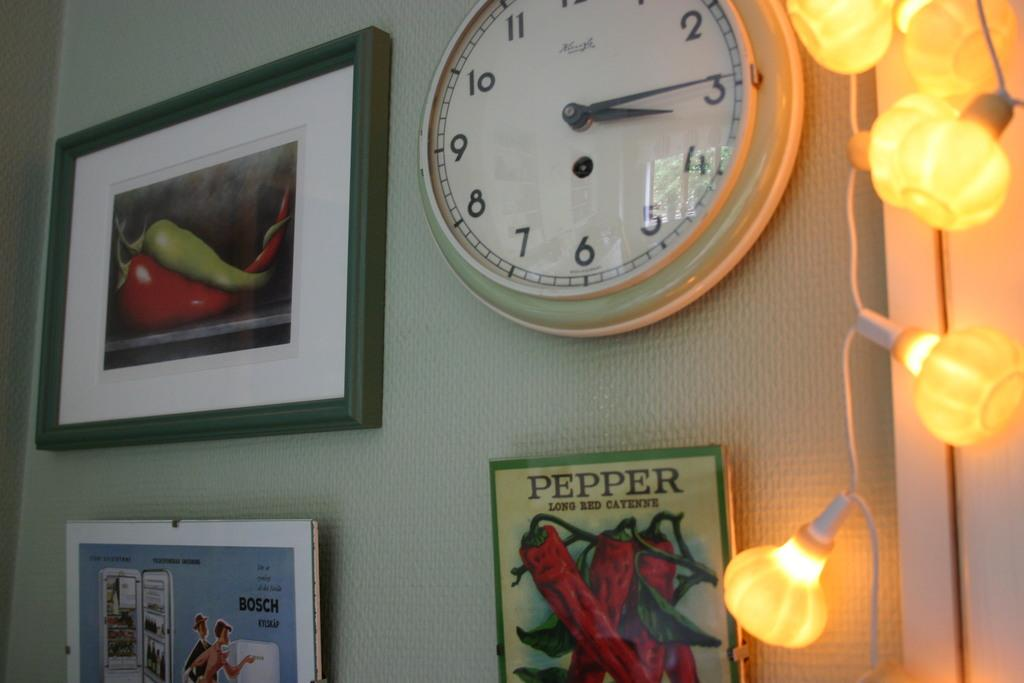<image>
Provide a brief description of the given image. A clock is on a wall by some framed art that says Pepper Long Red Cayenne. 